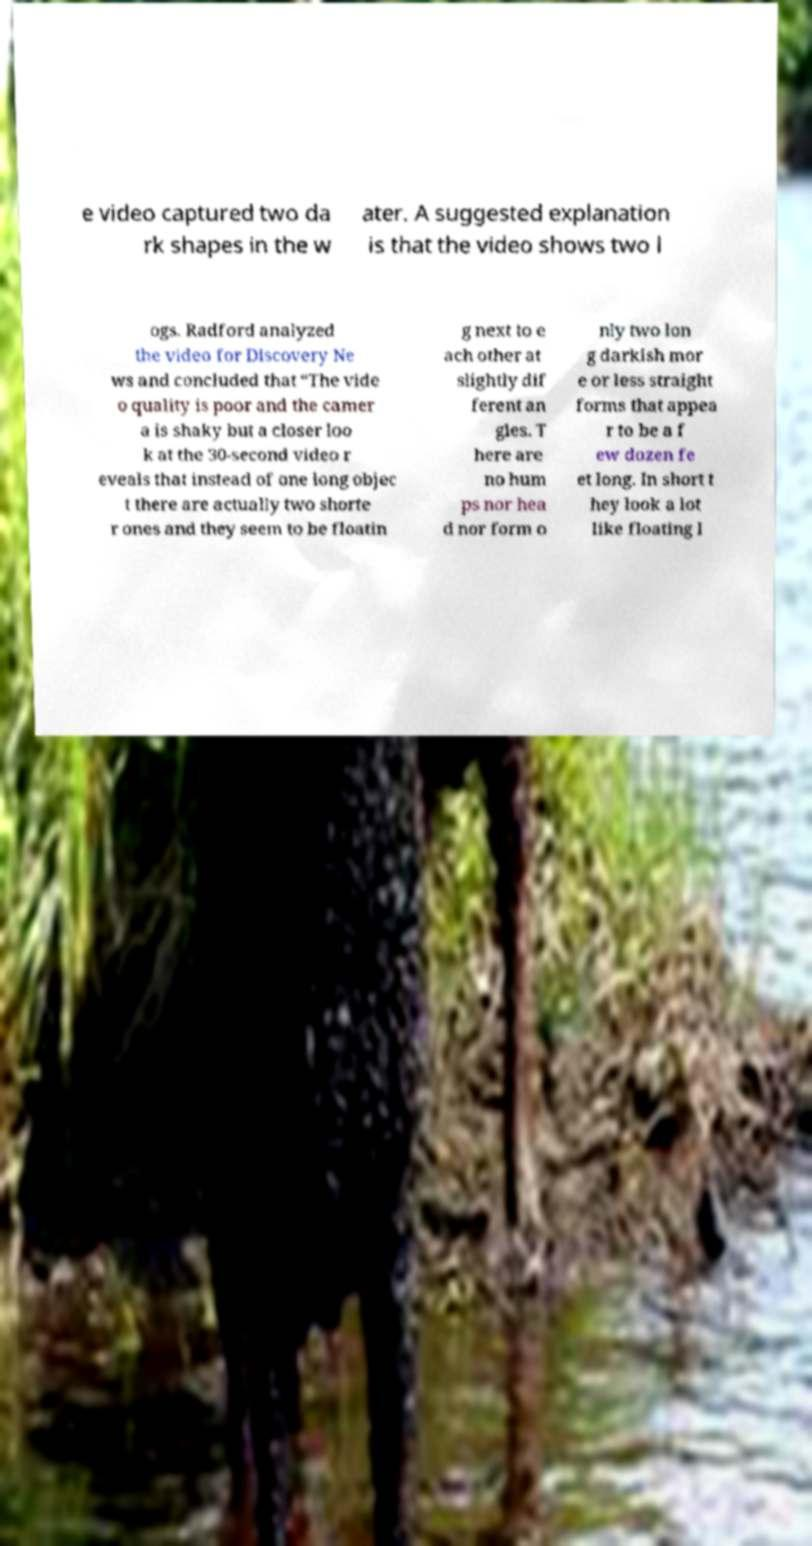There's text embedded in this image that I need extracted. Can you transcribe it verbatim? e video captured two da rk shapes in the w ater. A suggested explanation is that the video shows two l ogs. Radford analyzed the video for Discovery Ne ws and concluded that “The vide o quality is poor and the camer a is shaky but a closer loo k at the 30-second video r eveals that instead of one long objec t there are actually two shorte r ones and they seem to be floatin g next to e ach other at slightly dif ferent an gles. T here are no hum ps nor hea d nor form o nly two lon g darkish mor e or less straight forms that appea r to be a f ew dozen fe et long. In short t hey look a lot like floating l 